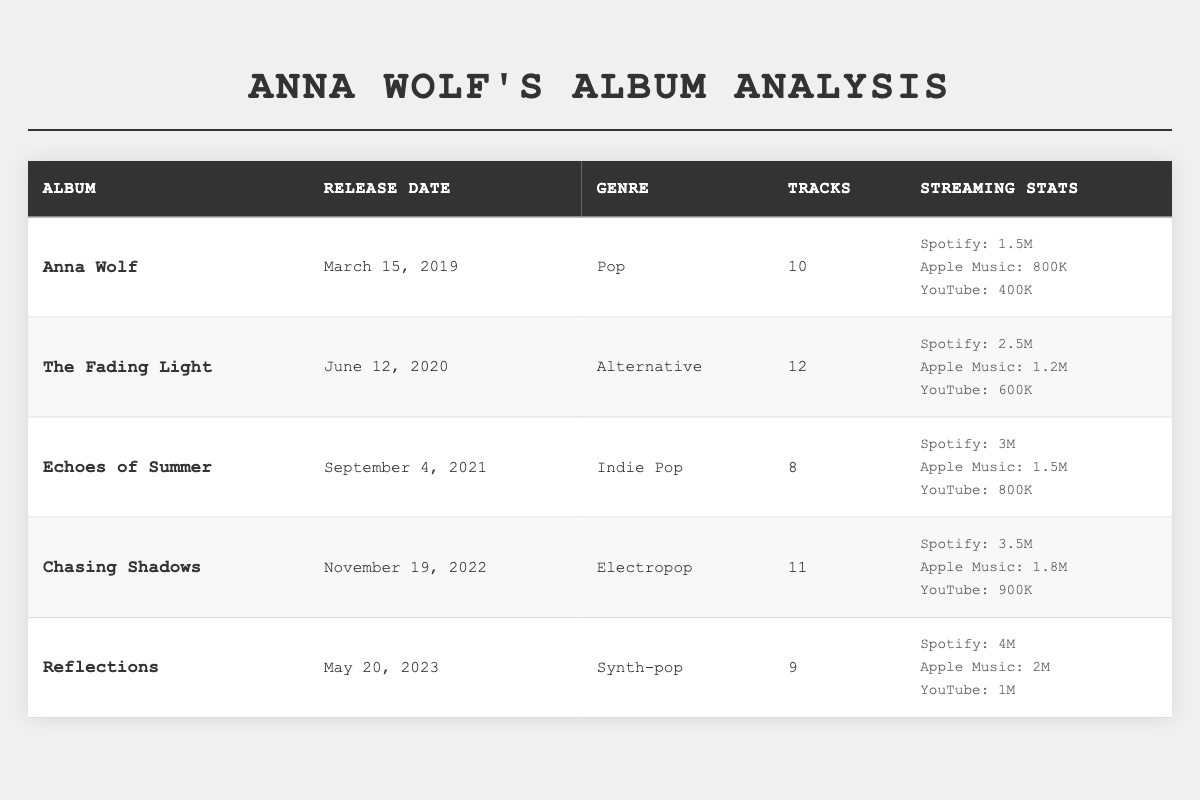What is the genre of "Chasing Shadows"? The genre can be found in the table under the entry for "Chasing Shadows," which lists "Electropop" as its genre.
Answer: Electropop Which album has the highest number of Spotify streams? By looking at the Spotify streams data in the table, "Reflections" has 4 million streams, more than any other album.
Answer: Reflections How many tracks are there in "Echoes of Summer"? The number of tracks for "Echoes of Summer" is shown in the corresponding column of the table, which states it has 8 tracks.
Answer: 8 What is the total number of tracks across all albums? To find the total number of tracks, sum the tracks for each album: 10 + 12 + 8 + 11 + 9 = 50.
Answer: 50 True or False: "The Fading Light" has more Apple Music streams than "Chasing Shadows." "The Fading Light" has 1.2 million streams, and "Chasing Shadows" has 1.8 million streams, so the statement is false.
Answer: False What is the difference in YouTube views between "Reflections" and "Anna Wolf"? "Reflections" has 1 million views and "Anna Wolf" has 400,000 views. The difference is 1,000,000 - 400,000 = 600,000 views.
Answer: 600,000 Which album was released most recently and how many Spotify streams does it have? The table indicates that "Reflections" was released on May 20, 2023, and it has 4 million Spotify streams.
Answer: Reflections, 4 million What is the average number of Spotify streams across all albums? To find the average, sum the Spotify streams: 1.5M + 2.5M + 3M + 3.5M + 4M = 14.5M, then divide by 5 albums: 14.5M / 5 = 2.9M.
Answer: 2.9 million Which album has the least YouTube views and what are the views? By comparing the YouTube views, "Anna Wolf" has the least views with 400,000.
Answer: Anna Wolf, 400,000 Does "Echoes of Summer" have more Apple Music streams than "Reflections"? "Echoes of Summer" has 1.5 million streams while "Reflections" has 2 million, so the statement is false.
Answer: False 